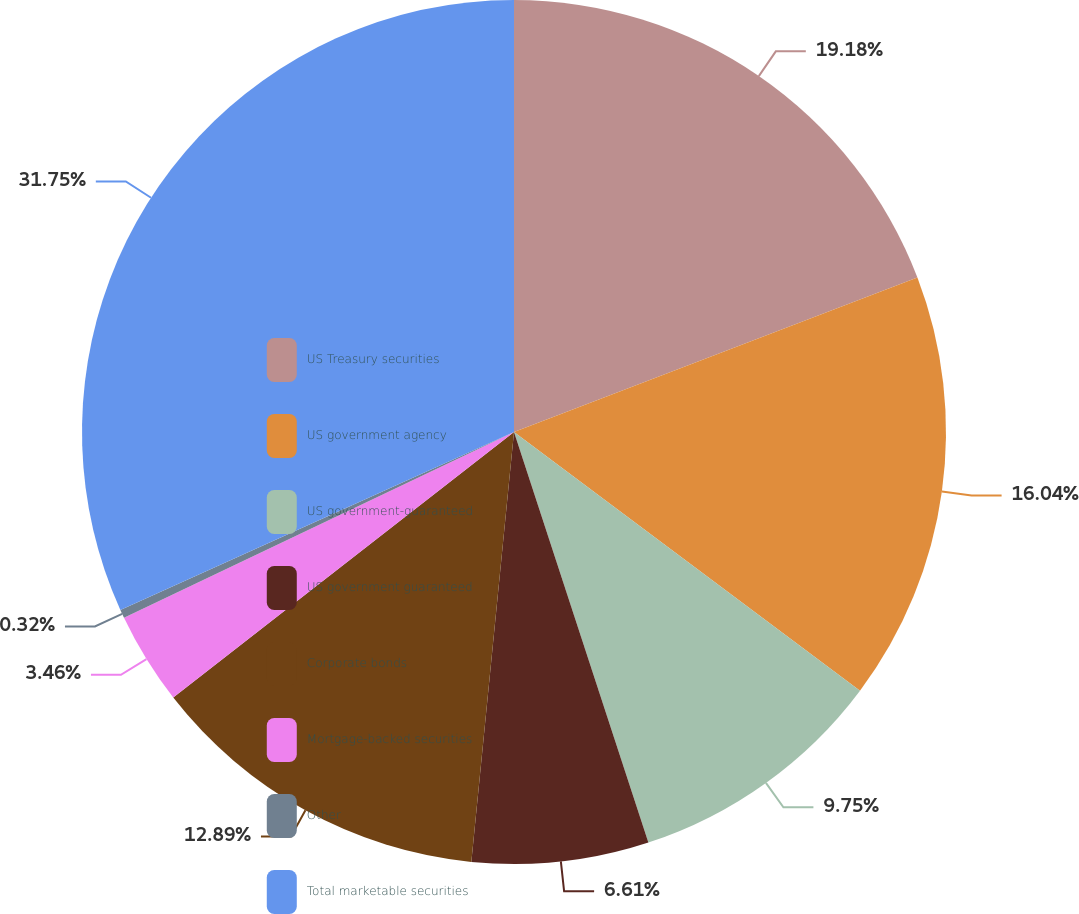<chart> <loc_0><loc_0><loc_500><loc_500><pie_chart><fcel>US Treasury securities<fcel>US government agency<fcel>US government-guaranteed<fcel>US government guaranteed<fcel>Corporate bonds<fcel>Mortgage-backed securities<fcel>Other<fcel>Total marketable securities<nl><fcel>19.18%<fcel>16.04%<fcel>9.75%<fcel>6.61%<fcel>12.89%<fcel>3.46%<fcel>0.32%<fcel>31.76%<nl></chart> 